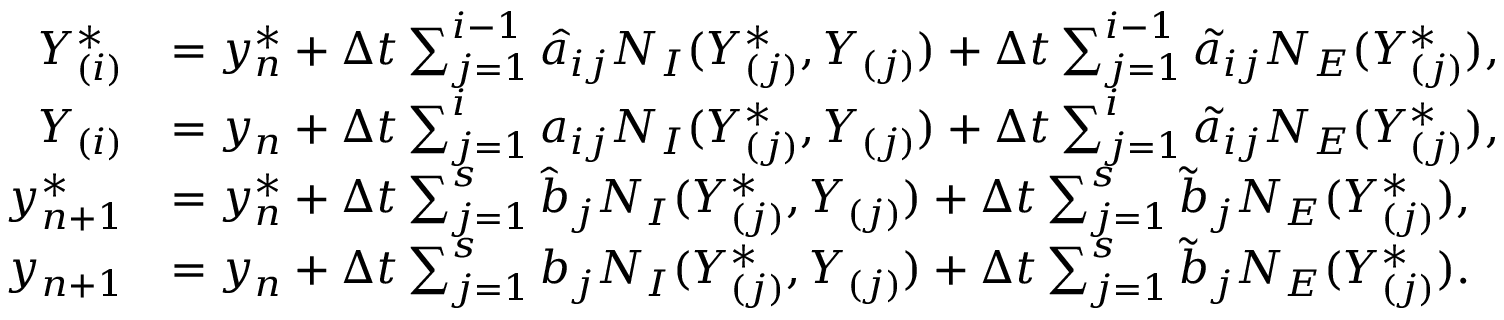<formula> <loc_0><loc_0><loc_500><loc_500>\begin{array} { r l } { Y _ { ( i ) } ^ { * } } & { = y _ { n } ^ { * } + \Delta t \sum _ { j = 1 } ^ { i - 1 } \hat { a } _ { i j } N _ { I } ( Y _ { ( j ) } ^ { * } , Y _ { ( j ) } ) + \Delta t \sum _ { j = 1 } ^ { i - 1 } \tilde { a } _ { i j } N _ { E } ( Y _ { ( j ) } ^ { * } ) , } \\ { Y _ { ( i ) } } & { = y _ { n } + \Delta t \sum _ { j = 1 } ^ { i } a _ { i j } N _ { I } ( Y _ { ( j ) } ^ { * } , Y _ { ( j ) } ) + \Delta t \sum _ { j = 1 } ^ { i } \tilde { a } _ { i j } N _ { E } ( Y _ { ( j ) } ^ { * } ) , } \\ { y _ { n + 1 } ^ { * } } & { = y _ { n } ^ { * } + \Delta t \sum _ { j = 1 } ^ { s } \hat { b } _ { j } N _ { I } ( Y _ { ( j ) } ^ { * } , Y _ { ( j ) } ) + \Delta t \sum _ { j = 1 } ^ { s } \tilde { b } _ { j } N _ { E } ( Y _ { ( j ) } ^ { * } ) , } \\ { y _ { n + 1 } } & { = y _ { n } + \Delta t \sum _ { j = 1 } ^ { s } b _ { j } N _ { I } ( Y _ { ( j ) } ^ { * } , Y _ { ( j ) } ) + \Delta t \sum _ { j = 1 } ^ { s } \tilde { b } _ { j } N _ { E } ( Y _ { ( j ) } ^ { * } ) . } \end{array}</formula> 